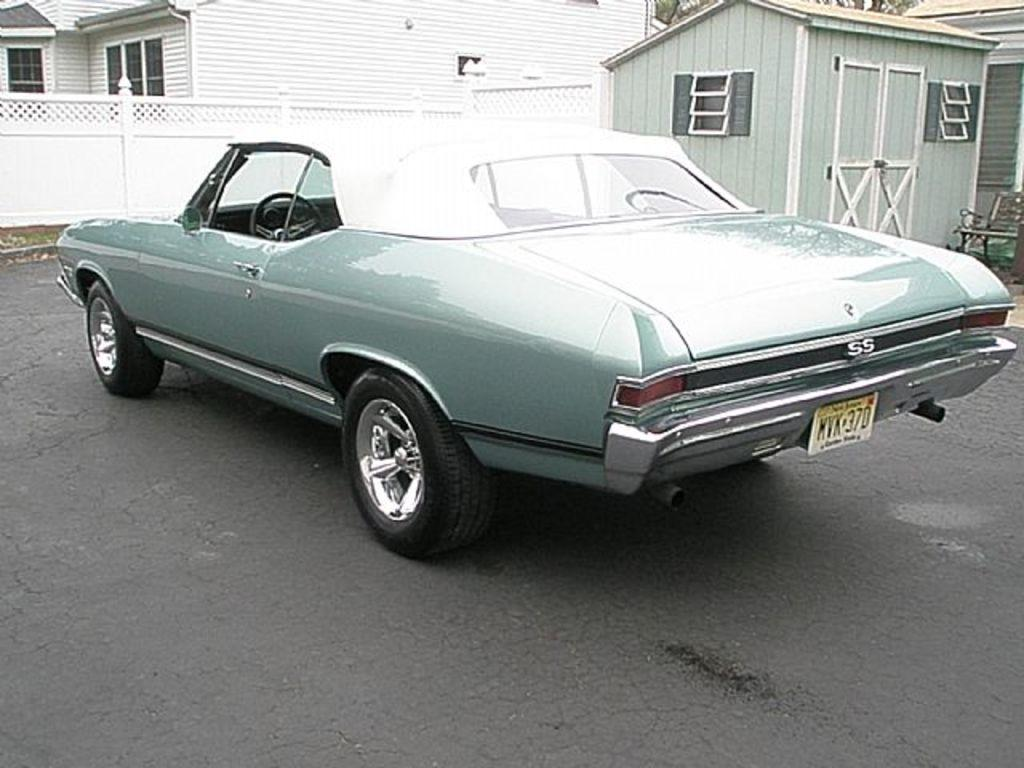What is the main feature of the image? There is a road in the image. What can be seen on the road? There is a car on the road. What color is the wall in the image? The wall in the image is white. What is visible in the background of the image? There is a white color house in the background of the image. What type of metal is the father using for trade in the image? There is no father or trade present in the image; it only features a road, a car, a white wall, and a white house in the background. 